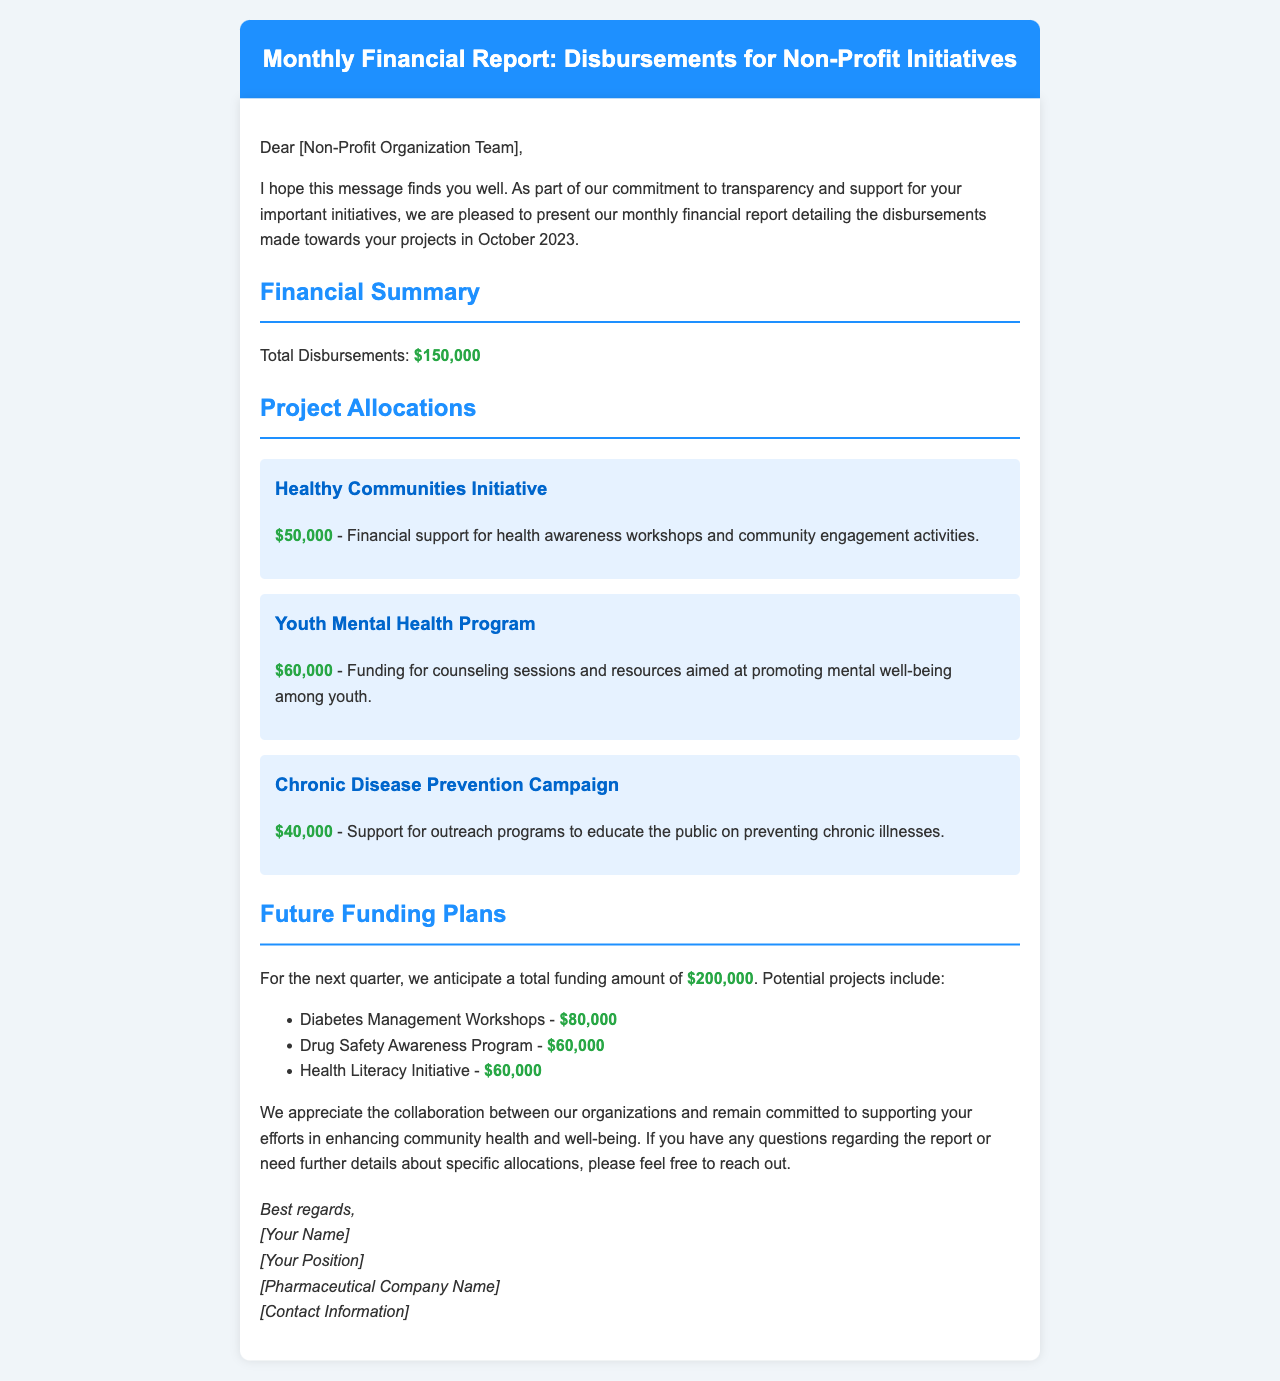What is the total amount of disbursements? The total amount of disbursements is listed in the financial summary section of the document.
Answer: $150,000 How much was allocated for the Youth Mental Health Program? The allocation for the Youth Mental Health Program is stated under Project Allocations.
Answer: $60,000 What is the future funding amount anticipated for the next quarter? The future funding amount is mentioned in the Future Funding Plans section.
Answer: $200,000 Which project has the highest funding allocation in the current report? The project with the highest allocation is determined by comparing the amounts listed under Project Allocations.
Answer: Youth Mental Health Program What are the proposed amounts for the Diabetes Management Workshops? The proposed amounts are listed under Future Funding Plans, where specific project amounts are outlined.
Answer: $80,000 